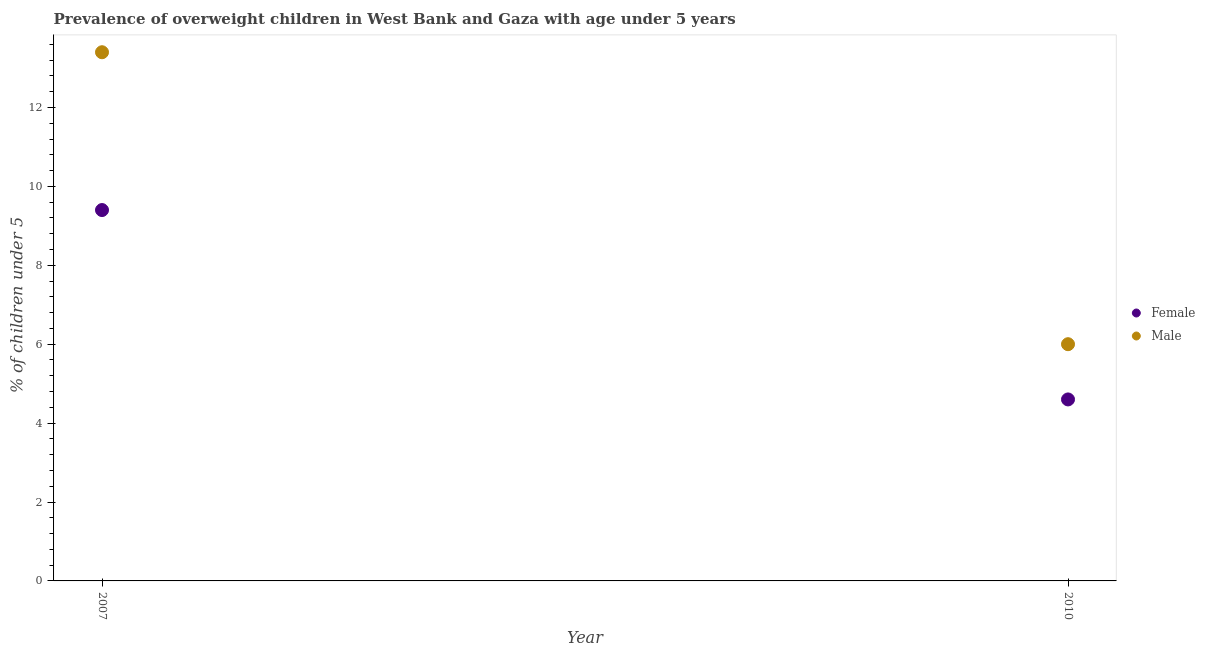Is the number of dotlines equal to the number of legend labels?
Your answer should be very brief. Yes. What is the percentage of obese female children in 2007?
Provide a short and direct response. 9.4. Across all years, what is the maximum percentage of obese male children?
Provide a succinct answer. 13.4. Across all years, what is the minimum percentage of obese female children?
Offer a terse response. 4.6. In which year was the percentage of obese male children maximum?
Make the answer very short. 2007. In which year was the percentage of obese male children minimum?
Your answer should be compact. 2010. What is the total percentage of obese male children in the graph?
Give a very brief answer. 19.4. What is the difference between the percentage of obese male children in 2007 and that in 2010?
Provide a short and direct response. 7.4. What is the difference between the percentage of obese female children in 2007 and the percentage of obese male children in 2010?
Provide a short and direct response. 3.4. What is the average percentage of obese female children per year?
Your response must be concise. 7. In the year 2010, what is the difference between the percentage of obese male children and percentage of obese female children?
Offer a very short reply. 1.4. In how many years, is the percentage of obese male children greater than 6.8 %?
Ensure brevity in your answer.  1. What is the ratio of the percentage of obese female children in 2007 to that in 2010?
Give a very brief answer. 2.04. Is the percentage of obese female children strictly greater than the percentage of obese male children over the years?
Your answer should be compact. No. Is the percentage of obese male children strictly less than the percentage of obese female children over the years?
Offer a terse response. No. How many years are there in the graph?
Give a very brief answer. 2. Are the values on the major ticks of Y-axis written in scientific E-notation?
Ensure brevity in your answer.  No. How many legend labels are there?
Ensure brevity in your answer.  2. What is the title of the graph?
Provide a short and direct response. Prevalence of overweight children in West Bank and Gaza with age under 5 years. Does "Researchers" appear as one of the legend labels in the graph?
Provide a succinct answer. No. What is the label or title of the X-axis?
Provide a succinct answer. Year. What is the label or title of the Y-axis?
Provide a succinct answer.  % of children under 5. What is the  % of children under 5 of Female in 2007?
Keep it short and to the point. 9.4. What is the  % of children under 5 in Male in 2007?
Your answer should be very brief. 13.4. What is the  % of children under 5 of Female in 2010?
Keep it short and to the point. 4.6. Across all years, what is the maximum  % of children under 5 in Female?
Make the answer very short. 9.4. Across all years, what is the maximum  % of children under 5 in Male?
Provide a succinct answer. 13.4. Across all years, what is the minimum  % of children under 5 of Female?
Offer a terse response. 4.6. Across all years, what is the minimum  % of children under 5 of Male?
Make the answer very short. 6. What is the total  % of children under 5 in Female in the graph?
Provide a succinct answer. 14. What is the average  % of children under 5 in Female per year?
Your answer should be very brief. 7. In the year 2010, what is the difference between the  % of children under 5 of Female and  % of children under 5 of Male?
Offer a terse response. -1.4. What is the ratio of the  % of children under 5 of Female in 2007 to that in 2010?
Your response must be concise. 2.04. What is the ratio of the  % of children under 5 of Male in 2007 to that in 2010?
Ensure brevity in your answer.  2.23. What is the difference between the highest and the lowest  % of children under 5 of Female?
Provide a succinct answer. 4.8. 